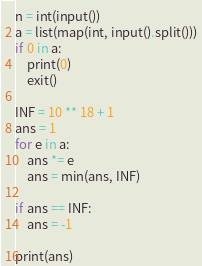<code> <loc_0><loc_0><loc_500><loc_500><_Python_>n = int(input())
a = list(map(int, input().split()))
if 0 in a:
    print(0)
    exit()

INF = 10 ** 18 + 1
ans = 1
for e in a:
    ans *= e
    ans = min(ans, INF)

if ans == INF:
    ans = -1

print(ans)
</code> 